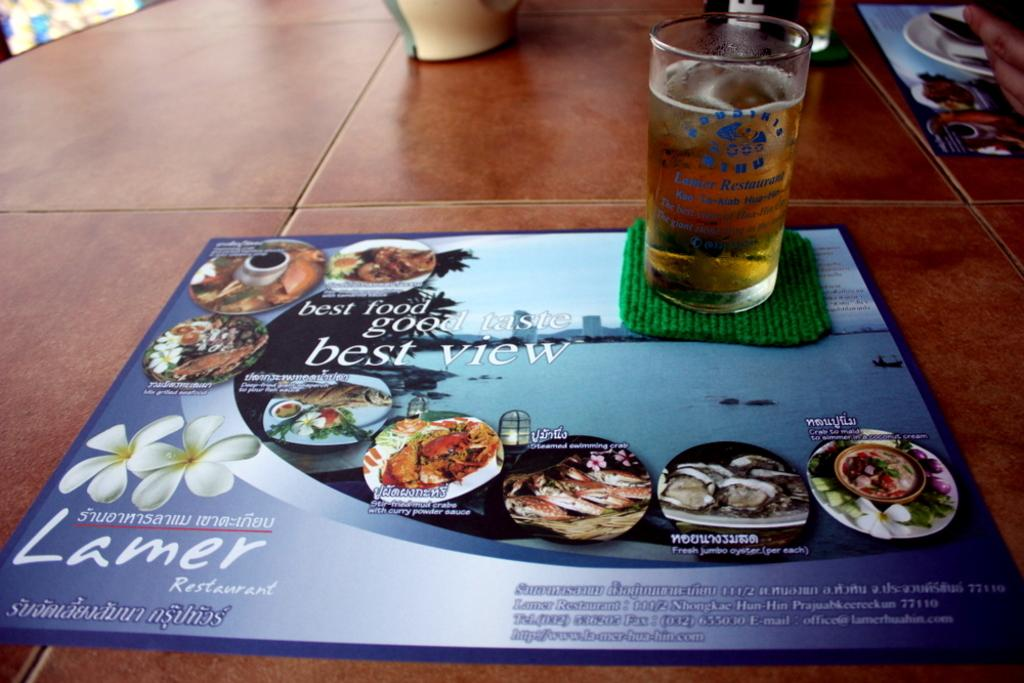What is in the glass that is visible in the image? There is a drink in the glass in the image. What other objects can be seen on the table in the image? There is a board, a plate, and a spoon visible in the image. Whose hand is visible in the image? A person's hand is visible in the image. What surface are all these objects placed on? All of these objects are on a table. What type of snake is slithering across the table in the image? There is no snake present in the image; it only features a glass with a drink, a board, a plate, a spoon, and a person's hand on a table. 